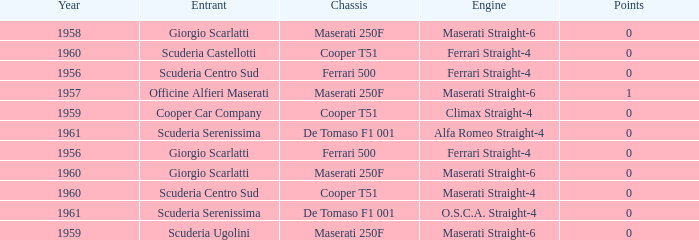How many points for the cooper car company after 1959? None. 